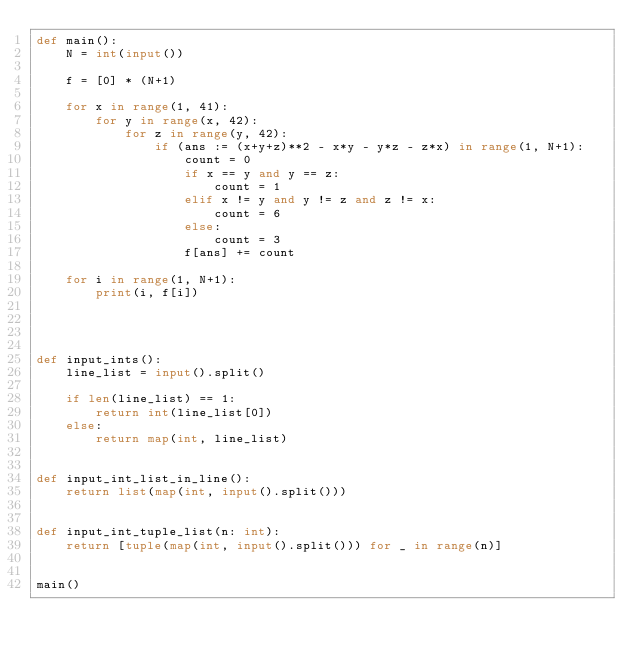<code> <loc_0><loc_0><loc_500><loc_500><_Python_>def main():
    N = int(input())

    f = [0] * (N+1)

    for x in range(1, 41):
        for y in range(x, 42):
            for z in range(y, 42):
                if (ans := (x+y+z)**2 - x*y - y*z - z*x) in range(1, N+1):
                    count = 0
                    if x == y and y == z:
                        count = 1
                    elif x != y and y != z and z != x:
                        count = 6
                    else:
                        count = 3
                    f[ans] += count
    
    for i in range(1, N+1):
        print(i, f[i])




def input_ints():
    line_list = input().split()

    if len(line_list) == 1:
        return int(line_list[0])
    else:
        return map(int, line_list)


def input_int_list_in_line():
    return list(map(int, input().split()))


def input_int_tuple_list(n: int):
    return [tuple(map(int, input().split())) for _ in range(n)]


main()
</code> 